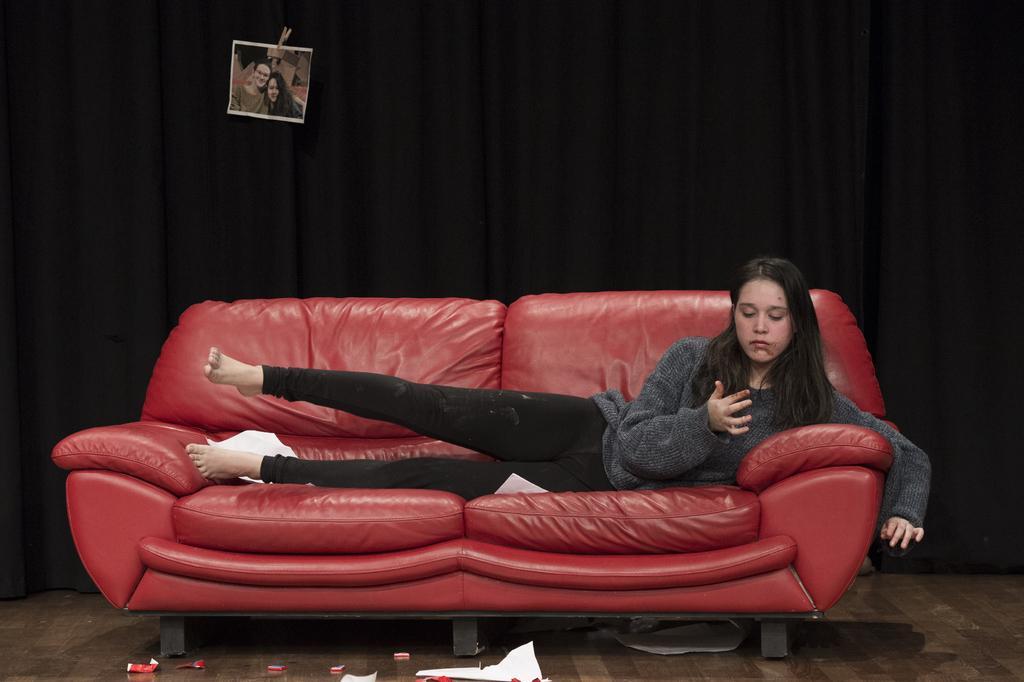In one or two sentences, can you explain what this image depicts? The women wearing black pant is sleeping on a red sofa and looking at her hand, In background there is a black curtain where a photo is attached to it. 